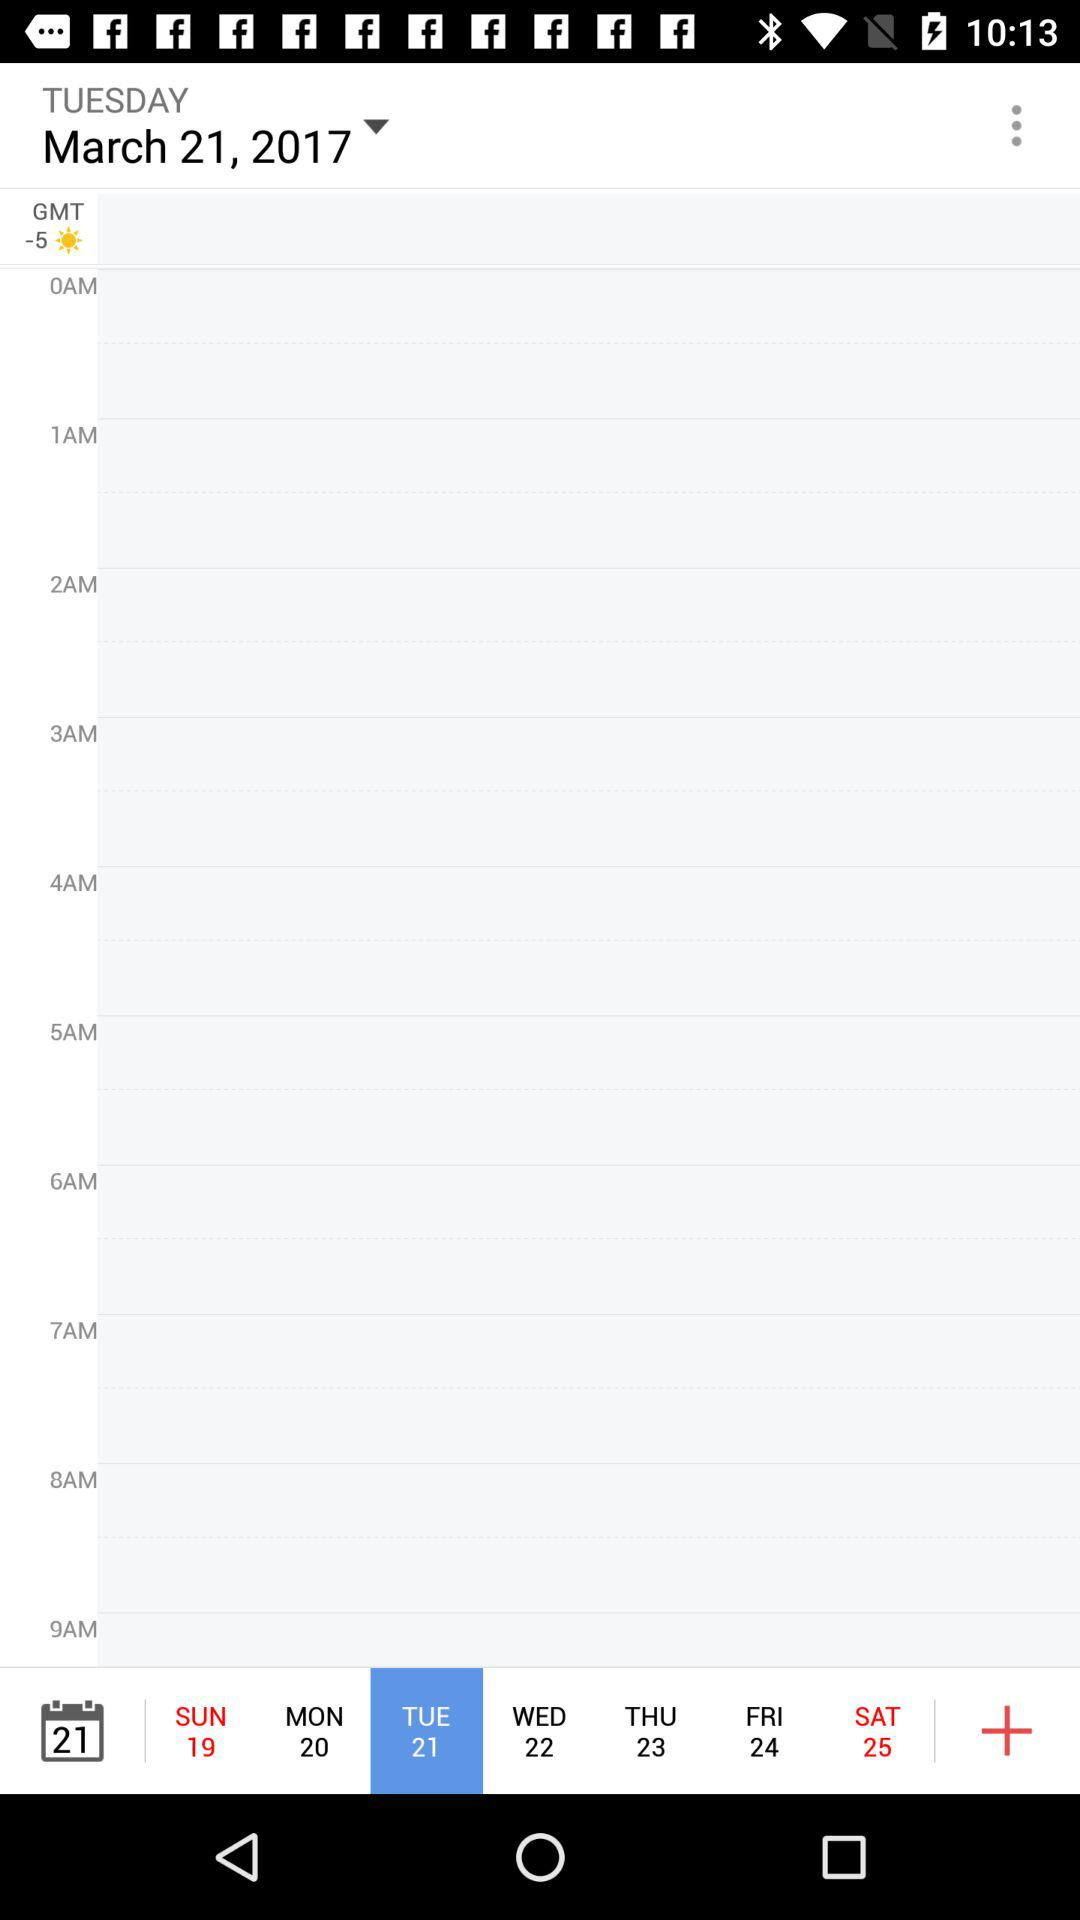How many hours are between 7am and 9am?
Answer the question using a single word or phrase. 2 